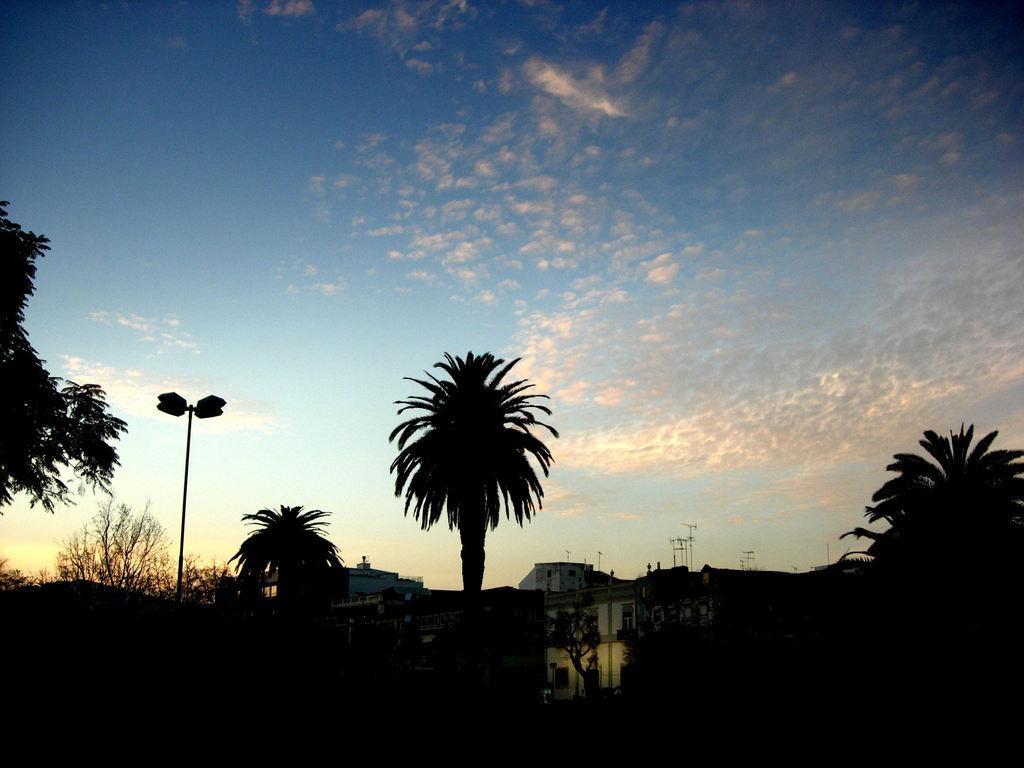How would you summarize this image in a sentence or two? In the image in the center we can see buildings,wall,poles,trees and plants. In the background we can see sky and clouds. 